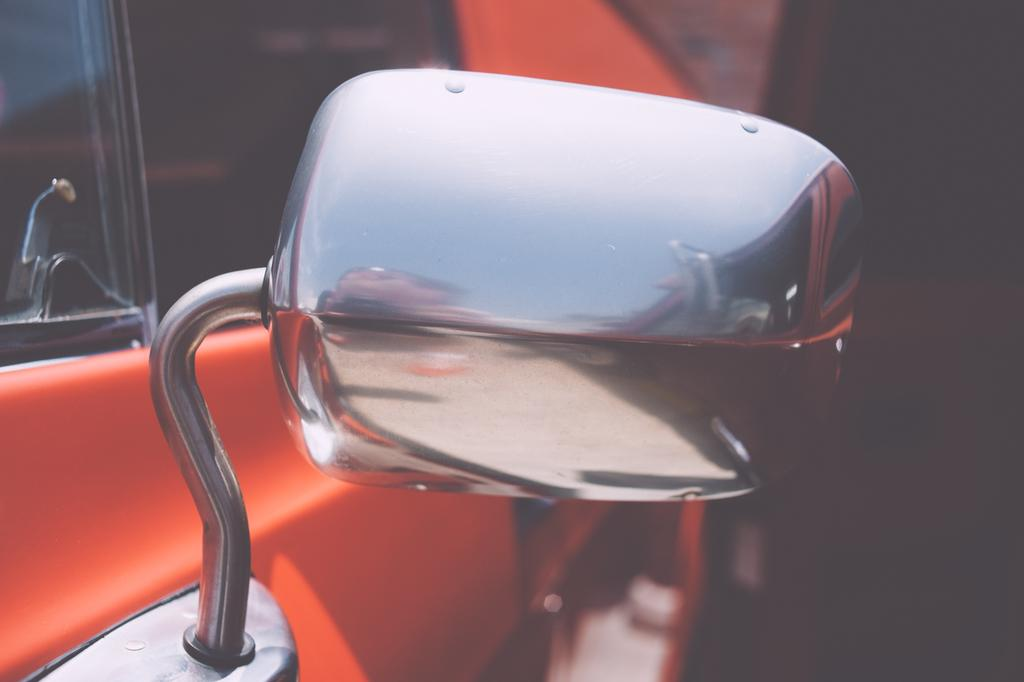What color is the car in the image? The car in the image is orange. What other feature can be seen on the car? The car has a silver mirror. Can you see a guitar being played in the image? There is no guitar or any indication of someone playing a guitar in the image. 